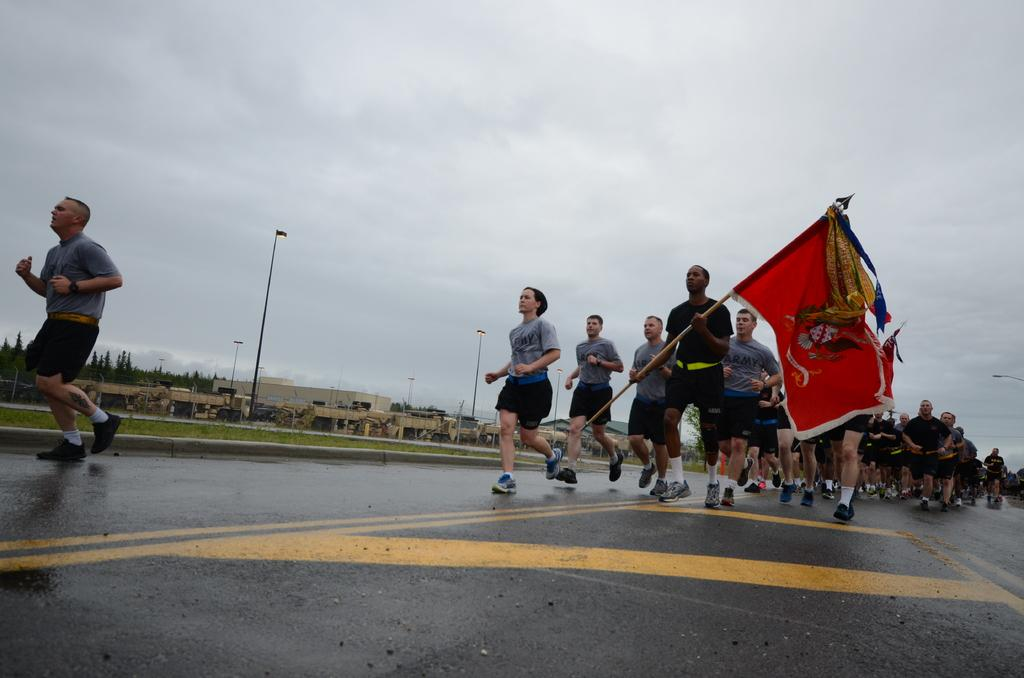What are the people in the image doing? The people in the image are running on the road. Can you describe any specific details about one of the people? One of the people is holding a flag. What can be seen in the background of the image? There are buildings and trees visible in the image. What type of structures are present in the image? There are poles in the image. What type of floor can be seen in the image? There is no floor visible in the image, as it features people running on a road. What type of bulb is used to illuminate the image? The image is a still photograph and does not require a bulb for illumination. 